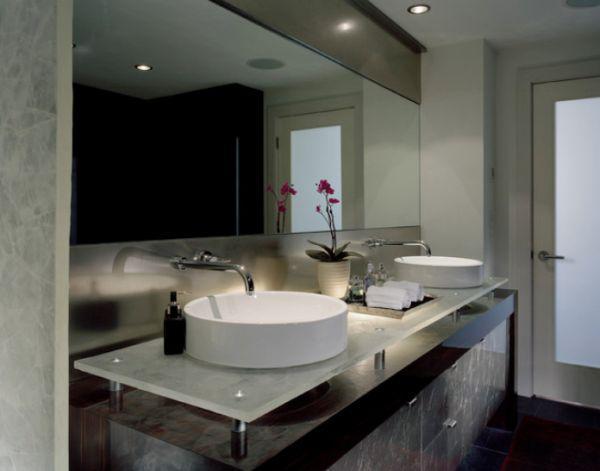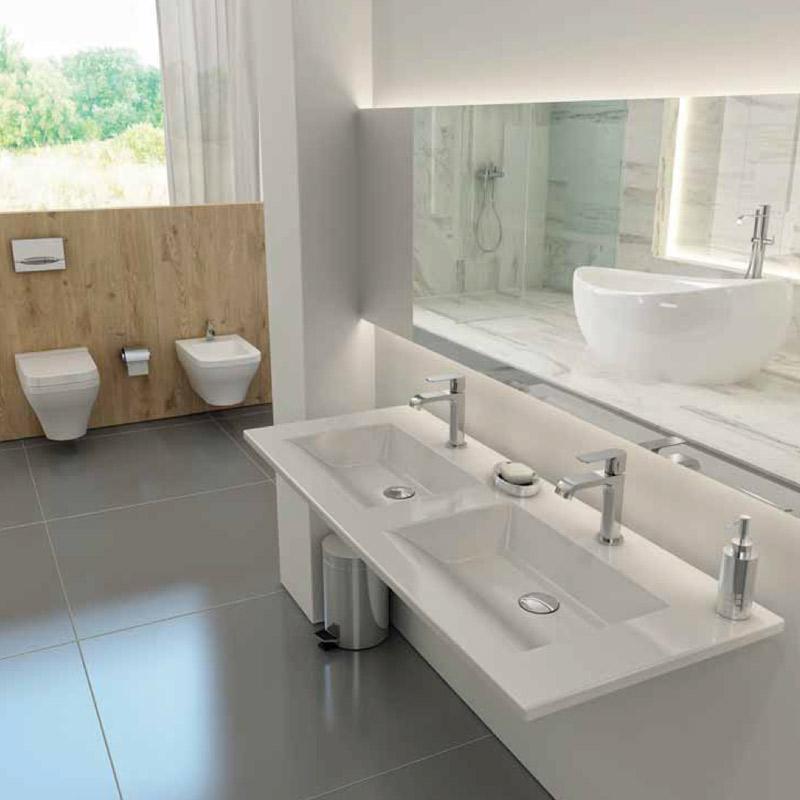The first image is the image on the left, the second image is the image on the right. Given the left and right images, does the statement "An image shows a vanity counter angled to the right with two separate white sinks sitting on top of the counter." hold true? Answer yes or no. Yes. The first image is the image on the left, the second image is the image on the right. For the images displayed, is the sentence "The flowers in the vase are pink." factually correct? Answer yes or no. Yes. 